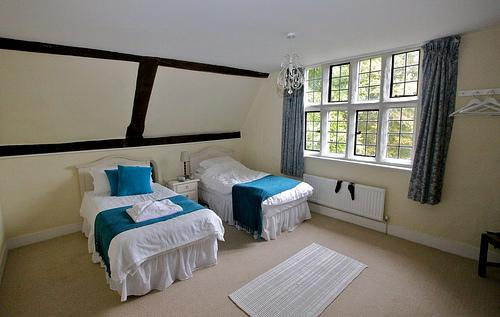Question: how many beds are in the room?
Choices:
A. 1.
B. 3.
C. 4.
D. 2.
Answer with the letter. Answer: D Question: why are there socks on the register?
Choices:
A. Laying there.
B. Child put there.
C. Drying.
D. Rolled up there.
Answer with the letter. Answer: C Question: what color are the pillows on 1 of the beds?
Choices:
A. Green.
B. Yellow.
C. Blue.
D. Red.
Answer with the letter. Answer: C 